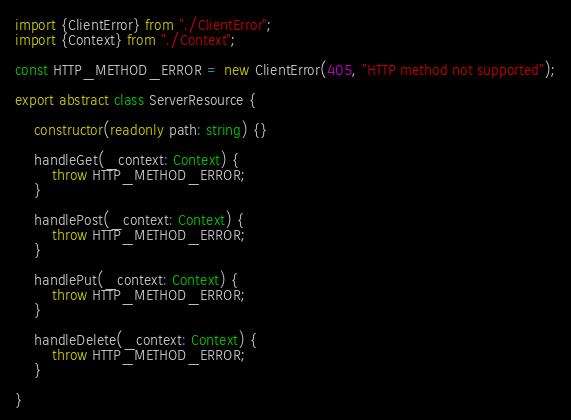<code> <loc_0><loc_0><loc_500><loc_500><_TypeScript_>import {ClientError} from "./ClientError";
import {Context} from "./Context";

const HTTP_METHOD_ERROR = new ClientError(405, "HTTP method not supported");

export abstract class ServerResource {

    constructor(readonly path: string) {}

    handleGet(_context: Context) {
        throw HTTP_METHOD_ERROR;
    }

    handlePost(_context: Context) {
        throw HTTP_METHOD_ERROR;
    }

    handlePut(_context: Context) {
        throw HTTP_METHOD_ERROR;
    }

    handleDelete(_context: Context) {
        throw HTTP_METHOD_ERROR;
    }

}
</code> 